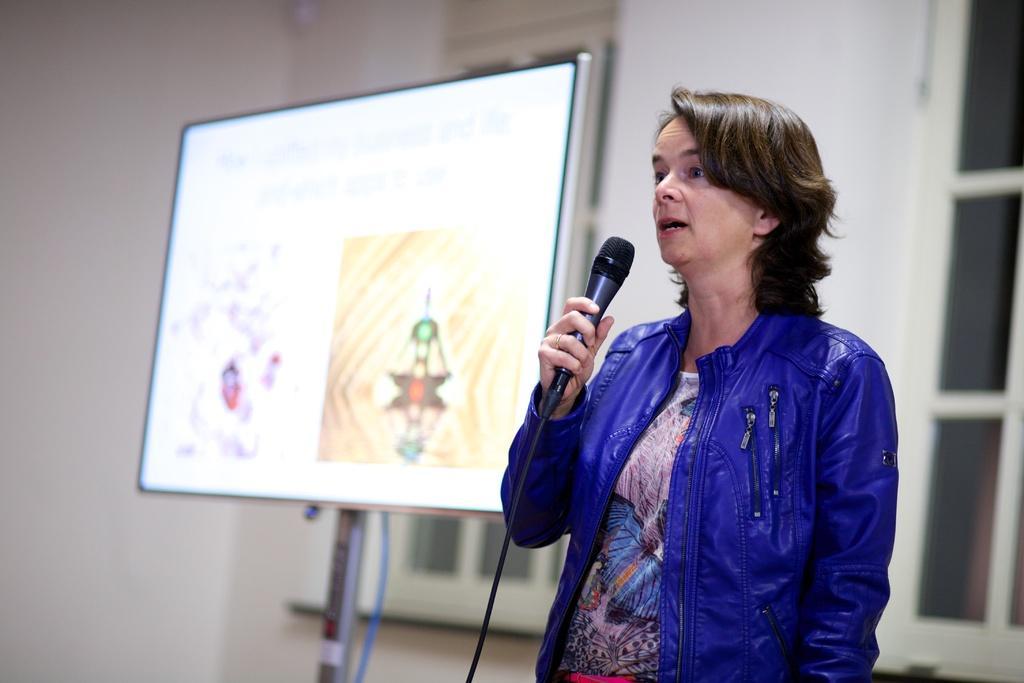How would you summarize this image in a sentence or two? In this picture we can see a woman holding a microphone in her hand. There is a screen on a pole. We can see a few windows and a wall in the background. 